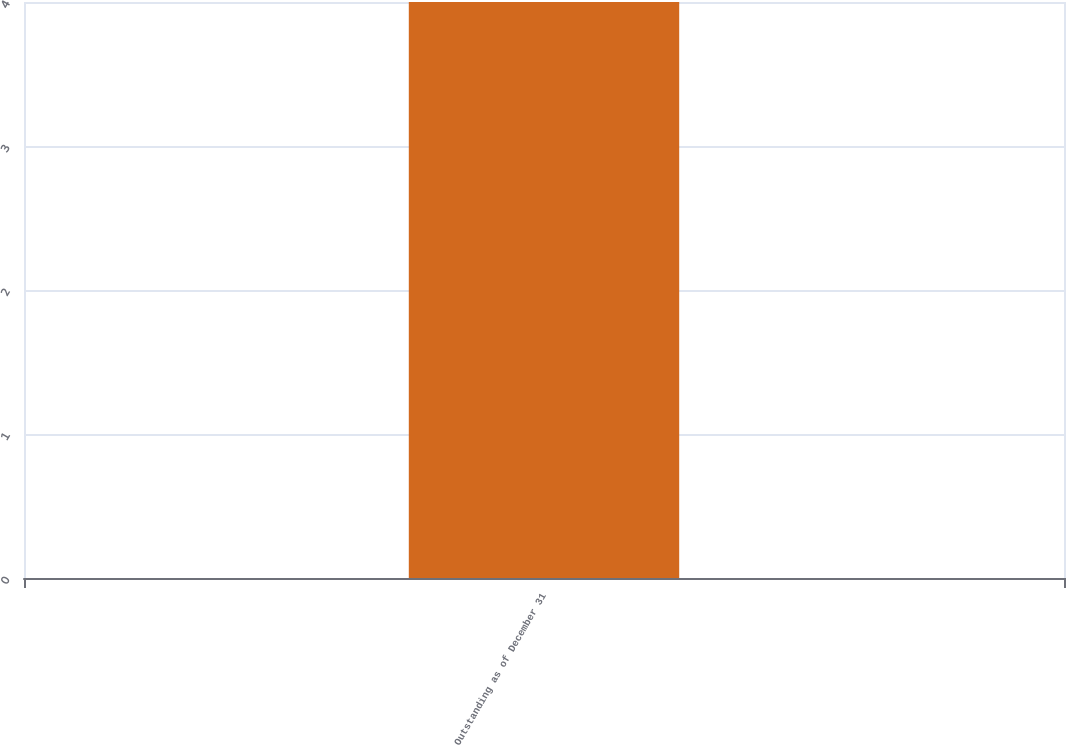Convert chart to OTSL. <chart><loc_0><loc_0><loc_500><loc_500><bar_chart><fcel>Outstanding as of December 31<nl><fcel>4<nl></chart> 